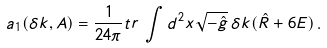Convert formula to latex. <formula><loc_0><loc_0><loc_500><loc_500>a _ { 1 } ( \delta k , A ) = \frac { 1 } { 2 4 \pi } { t r } \, \int d ^ { 2 } x \sqrt { - \hat { g } } \, \delta k ( \hat { R } + 6 E ) \, .</formula> 